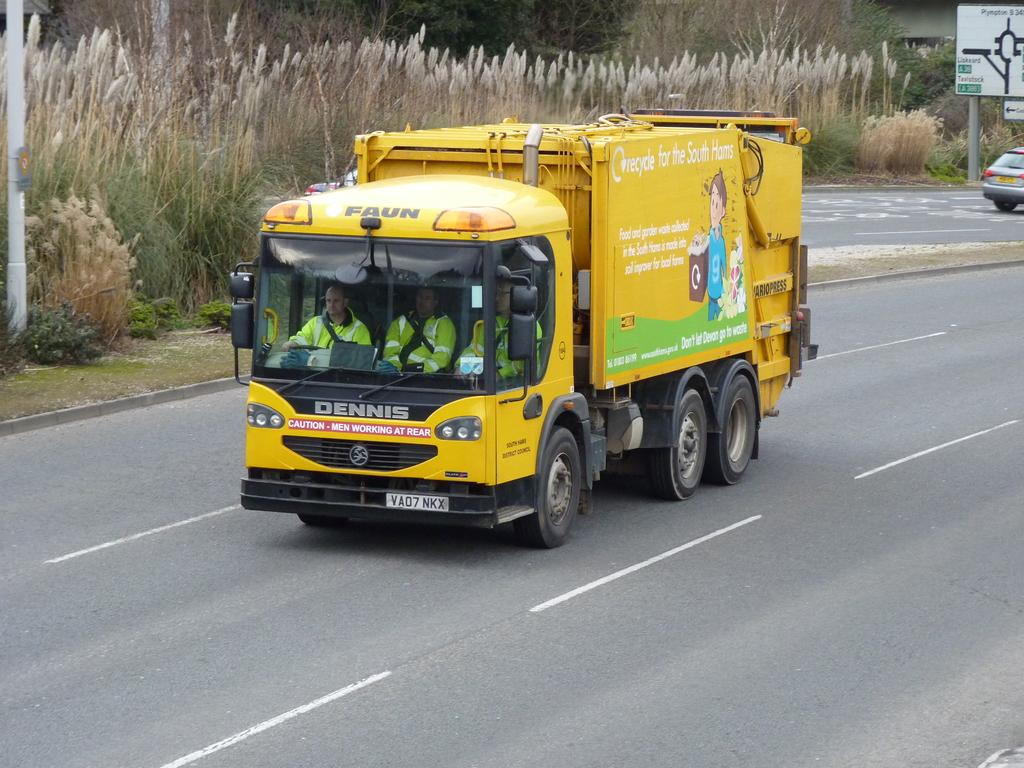What is the main subject in the center of the image? There is a truck in the center of the image. Where is the truck located? The truck is on the road. What can be seen in the background of the image? There is grass and trees in the background of the image. What additional object is present in the image? There is a sign board in the image. What type of eggnog is being sold at the market in the image? There is no market or eggnog present in the image; it features a truck on the road with a grass and tree background and a sign board. What does the driver of the truck regret in the image? There is no indication of regret or a driver in the image; it simply shows a truck on the road. 